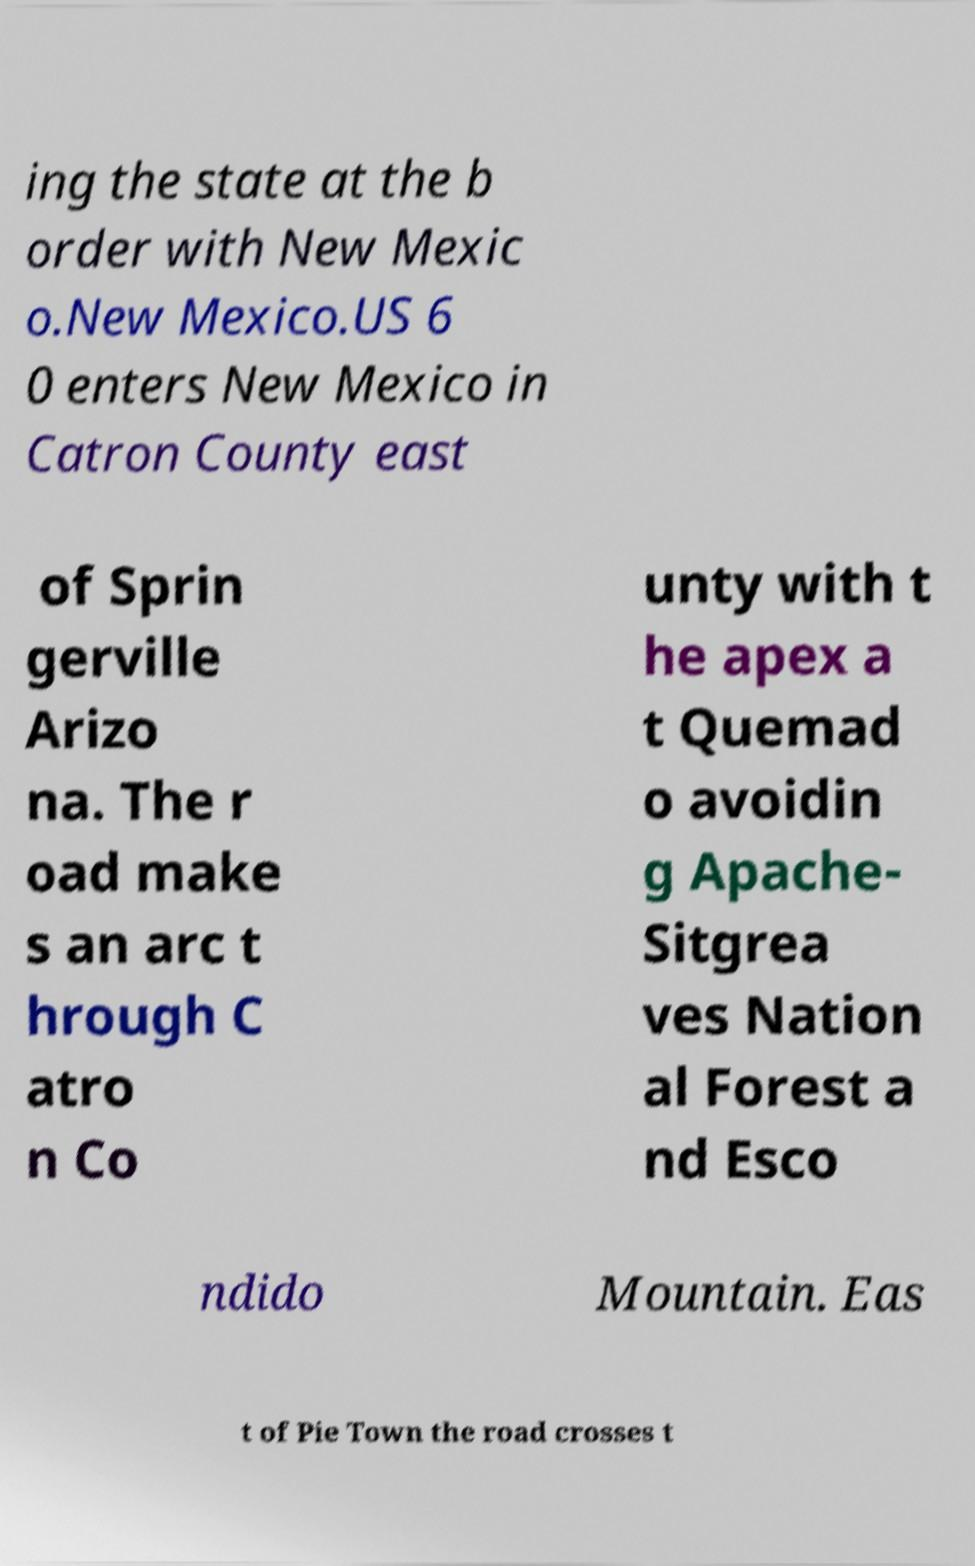For documentation purposes, I need the text within this image transcribed. Could you provide that? ing the state at the b order with New Mexic o.New Mexico.US 6 0 enters New Mexico in Catron County east of Sprin gerville Arizo na. The r oad make s an arc t hrough C atro n Co unty with t he apex a t Quemad o avoidin g Apache- Sitgrea ves Nation al Forest a nd Esco ndido Mountain. Eas t of Pie Town the road crosses t 